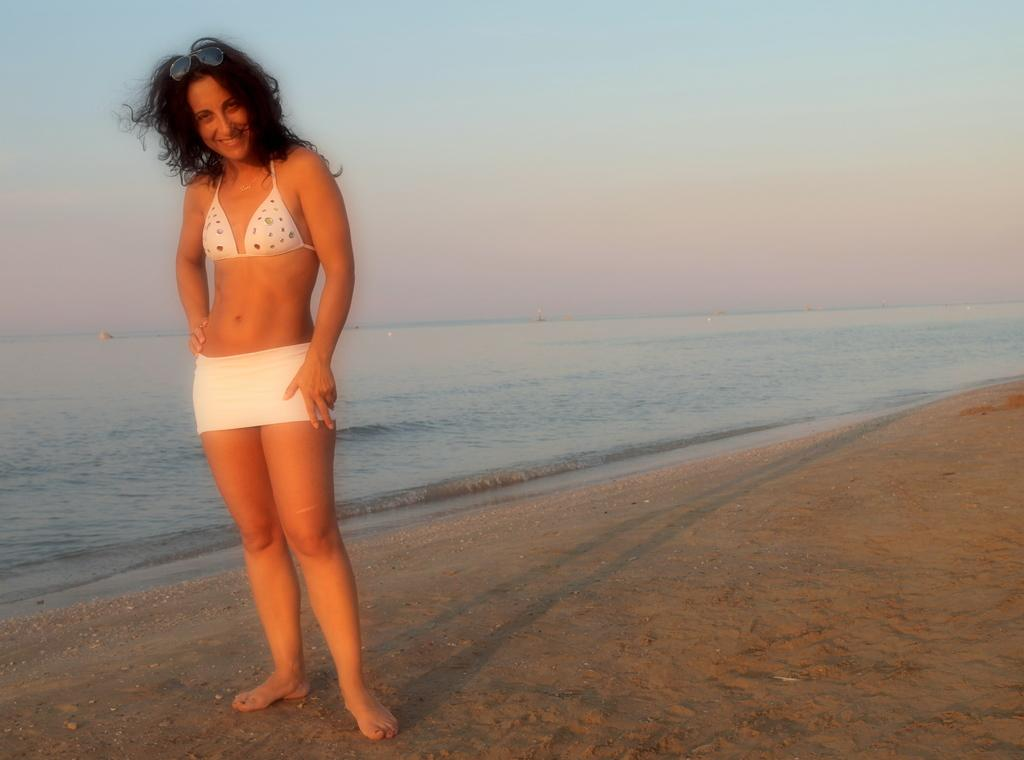Who is present in the image? There is a woman in the image. What is the woman doing in the image? The woman is standing in the image. What is the woman's facial expression in the image? The woman is smiling in the image. What natural element can be seen in the image? Water is visible in the image. What is visible in the background of the image? The sky is visible in the background of the image. How many trees are present in the cemetery in the image? There is no cemetery or trees present in the image; it features a woman standing near water with a visible sky in the background. 